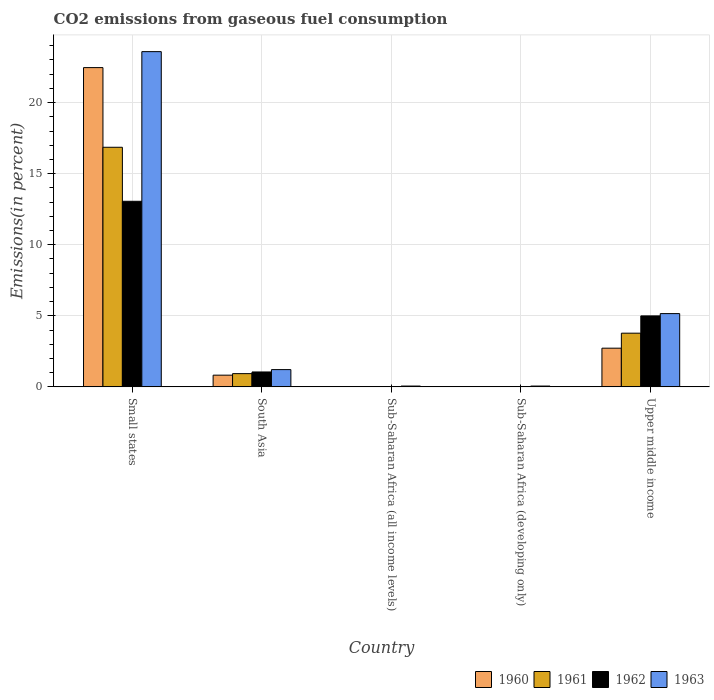How many different coloured bars are there?
Offer a terse response. 4. Are the number of bars on each tick of the X-axis equal?
Offer a terse response. Yes. How many bars are there on the 5th tick from the left?
Your answer should be very brief. 4. How many bars are there on the 2nd tick from the right?
Ensure brevity in your answer.  4. What is the label of the 1st group of bars from the left?
Your response must be concise. Small states. In how many cases, is the number of bars for a given country not equal to the number of legend labels?
Provide a succinct answer. 0. What is the total CO2 emitted in 1963 in Small states?
Provide a short and direct response. 23.59. Across all countries, what is the maximum total CO2 emitted in 1962?
Your answer should be compact. 13.06. Across all countries, what is the minimum total CO2 emitted in 1962?
Your answer should be compact. 0.01. In which country was the total CO2 emitted in 1962 maximum?
Make the answer very short. Small states. In which country was the total CO2 emitted in 1960 minimum?
Provide a succinct answer. Sub-Saharan Africa (all income levels). What is the total total CO2 emitted in 1962 in the graph?
Keep it short and to the point. 19.13. What is the difference between the total CO2 emitted in 1962 in Small states and that in Sub-Saharan Africa (all income levels)?
Ensure brevity in your answer.  13.04. What is the difference between the total CO2 emitted in 1960 in South Asia and the total CO2 emitted in 1962 in Sub-Saharan Africa (developing only)?
Offer a terse response. 0.81. What is the average total CO2 emitted in 1961 per country?
Give a very brief answer. 4.32. What is the difference between the total CO2 emitted of/in 1960 and total CO2 emitted of/in 1963 in Sub-Saharan Africa (developing only)?
Give a very brief answer. -0.05. In how many countries, is the total CO2 emitted in 1960 greater than 23 %?
Give a very brief answer. 0. What is the ratio of the total CO2 emitted in 1961 in Sub-Saharan Africa (developing only) to that in Upper middle income?
Keep it short and to the point. 0. Is the total CO2 emitted in 1963 in Small states less than that in Sub-Saharan Africa (developing only)?
Ensure brevity in your answer.  No. What is the difference between the highest and the second highest total CO2 emitted in 1961?
Make the answer very short. 15.93. What is the difference between the highest and the lowest total CO2 emitted in 1962?
Your answer should be compact. 13.04. In how many countries, is the total CO2 emitted in 1962 greater than the average total CO2 emitted in 1962 taken over all countries?
Your answer should be compact. 2. Is it the case that in every country, the sum of the total CO2 emitted in 1962 and total CO2 emitted in 1960 is greater than the sum of total CO2 emitted in 1961 and total CO2 emitted in 1963?
Keep it short and to the point. No. What does the 4th bar from the left in Sub-Saharan Africa (all income levels) represents?
Provide a short and direct response. 1963. What does the 2nd bar from the right in Sub-Saharan Africa (developing only) represents?
Offer a terse response. 1962. Is it the case that in every country, the sum of the total CO2 emitted in 1963 and total CO2 emitted in 1962 is greater than the total CO2 emitted in 1961?
Ensure brevity in your answer.  Yes. How many countries are there in the graph?
Offer a terse response. 5. What is the difference between two consecutive major ticks on the Y-axis?
Offer a terse response. 5. What is the title of the graph?
Ensure brevity in your answer.  CO2 emissions from gaseous fuel consumption. Does "1970" appear as one of the legend labels in the graph?
Ensure brevity in your answer.  No. What is the label or title of the X-axis?
Offer a very short reply. Country. What is the label or title of the Y-axis?
Offer a very short reply. Emissions(in percent). What is the Emissions(in percent) in 1960 in Small states?
Provide a short and direct response. 22.46. What is the Emissions(in percent) in 1961 in Small states?
Provide a succinct answer. 16.86. What is the Emissions(in percent) of 1962 in Small states?
Offer a very short reply. 13.06. What is the Emissions(in percent) in 1963 in Small states?
Keep it short and to the point. 23.59. What is the Emissions(in percent) in 1960 in South Asia?
Provide a short and direct response. 0.82. What is the Emissions(in percent) in 1961 in South Asia?
Your response must be concise. 0.93. What is the Emissions(in percent) of 1962 in South Asia?
Provide a succinct answer. 1.05. What is the Emissions(in percent) of 1963 in South Asia?
Offer a terse response. 1.22. What is the Emissions(in percent) of 1960 in Sub-Saharan Africa (all income levels)?
Give a very brief answer. 0.01. What is the Emissions(in percent) in 1961 in Sub-Saharan Africa (all income levels)?
Provide a short and direct response. 0.01. What is the Emissions(in percent) in 1962 in Sub-Saharan Africa (all income levels)?
Provide a succinct answer. 0.01. What is the Emissions(in percent) in 1963 in Sub-Saharan Africa (all income levels)?
Your answer should be very brief. 0.06. What is the Emissions(in percent) in 1960 in Sub-Saharan Africa (developing only)?
Offer a very short reply. 0.01. What is the Emissions(in percent) of 1961 in Sub-Saharan Africa (developing only)?
Your answer should be very brief. 0.01. What is the Emissions(in percent) of 1962 in Sub-Saharan Africa (developing only)?
Your response must be concise. 0.01. What is the Emissions(in percent) of 1963 in Sub-Saharan Africa (developing only)?
Your answer should be very brief. 0.06. What is the Emissions(in percent) in 1960 in Upper middle income?
Provide a succinct answer. 2.72. What is the Emissions(in percent) in 1961 in Upper middle income?
Your answer should be very brief. 3.78. What is the Emissions(in percent) of 1962 in Upper middle income?
Offer a very short reply. 4.99. What is the Emissions(in percent) of 1963 in Upper middle income?
Keep it short and to the point. 5.15. Across all countries, what is the maximum Emissions(in percent) in 1960?
Your answer should be compact. 22.46. Across all countries, what is the maximum Emissions(in percent) of 1961?
Give a very brief answer. 16.86. Across all countries, what is the maximum Emissions(in percent) of 1962?
Your response must be concise. 13.06. Across all countries, what is the maximum Emissions(in percent) in 1963?
Make the answer very short. 23.59. Across all countries, what is the minimum Emissions(in percent) of 1960?
Your answer should be very brief. 0.01. Across all countries, what is the minimum Emissions(in percent) of 1961?
Keep it short and to the point. 0.01. Across all countries, what is the minimum Emissions(in percent) of 1962?
Offer a very short reply. 0.01. Across all countries, what is the minimum Emissions(in percent) of 1963?
Your response must be concise. 0.06. What is the total Emissions(in percent) in 1960 in the graph?
Ensure brevity in your answer.  26.03. What is the total Emissions(in percent) of 1961 in the graph?
Your response must be concise. 21.59. What is the total Emissions(in percent) in 1962 in the graph?
Offer a terse response. 19.13. What is the total Emissions(in percent) in 1963 in the graph?
Ensure brevity in your answer.  30.07. What is the difference between the Emissions(in percent) of 1960 in Small states and that in South Asia?
Keep it short and to the point. 21.64. What is the difference between the Emissions(in percent) in 1961 in Small states and that in South Asia?
Your response must be concise. 15.93. What is the difference between the Emissions(in percent) of 1962 in Small states and that in South Asia?
Your answer should be very brief. 12.01. What is the difference between the Emissions(in percent) in 1963 in Small states and that in South Asia?
Keep it short and to the point. 22.37. What is the difference between the Emissions(in percent) in 1960 in Small states and that in Sub-Saharan Africa (all income levels)?
Make the answer very short. 22.45. What is the difference between the Emissions(in percent) in 1961 in Small states and that in Sub-Saharan Africa (all income levels)?
Make the answer very short. 16.85. What is the difference between the Emissions(in percent) of 1962 in Small states and that in Sub-Saharan Africa (all income levels)?
Offer a very short reply. 13.04. What is the difference between the Emissions(in percent) in 1963 in Small states and that in Sub-Saharan Africa (all income levels)?
Offer a terse response. 23.53. What is the difference between the Emissions(in percent) in 1960 in Small states and that in Sub-Saharan Africa (developing only)?
Give a very brief answer. 22.45. What is the difference between the Emissions(in percent) of 1961 in Small states and that in Sub-Saharan Africa (developing only)?
Give a very brief answer. 16.85. What is the difference between the Emissions(in percent) in 1962 in Small states and that in Sub-Saharan Africa (developing only)?
Ensure brevity in your answer.  13.04. What is the difference between the Emissions(in percent) of 1963 in Small states and that in Sub-Saharan Africa (developing only)?
Your answer should be compact. 23.53. What is the difference between the Emissions(in percent) of 1960 in Small states and that in Upper middle income?
Ensure brevity in your answer.  19.74. What is the difference between the Emissions(in percent) of 1961 in Small states and that in Upper middle income?
Provide a short and direct response. 13.08. What is the difference between the Emissions(in percent) of 1962 in Small states and that in Upper middle income?
Offer a terse response. 8.06. What is the difference between the Emissions(in percent) of 1963 in Small states and that in Upper middle income?
Offer a terse response. 18.43. What is the difference between the Emissions(in percent) in 1960 in South Asia and that in Sub-Saharan Africa (all income levels)?
Provide a succinct answer. 0.81. What is the difference between the Emissions(in percent) of 1961 in South Asia and that in Sub-Saharan Africa (all income levels)?
Keep it short and to the point. 0.92. What is the difference between the Emissions(in percent) in 1962 in South Asia and that in Sub-Saharan Africa (all income levels)?
Keep it short and to the point. 1.03. What is the difference between the Emissions(in percent) of 1963 in South Asia and that in Sub-Saharan Africa (all income levels)?
Keep it short and to the point. 1.16. What is the difference between the Emissions(in percent) of 1960 in South Asia and that in Sub-Saharan Africa (developing only)?
Make the answer very short. 0.81. What is the difference between the Emissions(in percent) in 1961 in South Asia and that in Sub-Saharan Africa (developing only)?
Provide a short and direct response. 0.92. What is the difference between the Emissions(in percent) in 1962 in South Asia and that in Sub-Saharan Africa (developing only)?
Your answer should be compact. 1.03. What is the difference between the Emissions(in percent) of 1963 in South Asia and that in Sub-Saharan Africa (developing only)?
Your answer should be very brief. 1.16. What is the difference between the Emissions(in percent) of 1960 in South Asia and that in Upper middle income?
Offer a terse response. -1.9. What is the difference between the Emissions(in percent) of 1961 in South Asia and that in Upper middle income?
Make the answer very short. -2.85. What is the difference between the Emissions(in percent) of 1962 in South Asia and that in Upper middle income?
Your answer should be compact. -3.94. What is the difference between the Emissions(in percent) in 1963 in South Asia and that in Upper middle income?
Your answer should be very brief. -3.94. What is the difference between the Emissions(in percent) of 1960 in Sub-Saharan Africa (all income levels) and that in Sub-Saharan Africa (developing only)?
Your answer should be compact. -0. What is the difference between the Emissions(in percent) in 1961 in Sub-Saharan Africa (all income levels) and that in Sub-Saharan Africa (developing only)?
Your response must be concise. -0. What is the difference between the Emissions(in percent) in 1962 in Sub-Saharan Africa (all income levels) and that in Sub-Saharan Africa (developing only)?
Offer a very short reply. -0. What is the difference between the Emissions(in percent) of 1963 in Sub-Saharan Africa (all income levels) and that in Sub-Saharan Africa (developing only)?
Your response must be concise. -0. What is the difference between the Emissions(in percent) of 1960 in Sub-Saharan Africa (all income levels) and that in Upper middle income?
Offer a terse response. -2.71. What is the difference between the Emissions(in percent) of 1961 in Sub-Saharan Africa (all income levels) and that in Upper middle income?
Your answer should be very brief. -3.77. What is the difference between the Emissions(in percent) of 1962 in Sub-Saharan Africa (all income levels) and that in Upper middle income?
Give a very brief answer. -4.98. What is the difference between the Emissions(in percent) of 1963 in Sub-Saharan Africa (all income levels) and that in Upper middle income?
Provide a succinct answer. -5.1. What is the difference between the Emissions(in percent) of 1960 in Sub-Saharan Africa (developing only) and that in Upper middle income?
Provide a succinct answer. -2.71. What is the difference between the Emissions(in percent) of 1961 in Sub-Saharan Africa (developing only) and that in Upper middle income?
Offer a very short reply. -3.77. What is the difference between the Emissions(in percent) in 1962 in Sub-Saharan Africa (developing only) and that in Upper middle income?
Provide a succinct answer. -4.98. What is the difference between the Emissions(in percent) of 1963 in Sub-Saharan Africa (developing only) and that in Upper middle income?
Give a very brief answer. -5.1. What is the difference between the Emissions(in percent) of 1960 in Small states and the Emissions(in percent) of 1961 in South Asia?
Ensure brevity in your answer.  21.53. What is the difference between the Emissions(in percent) of 1960 in Small states and the Emissions(in percent) of 1962 in South Asia?
Keep it short and to the point. 21.41. What is the difference between the Emissions(in percent) of 1960 in Small states and the Emissions(in percent) of 1963 in South Asia?
Your answer should be very brief. 21.25. What is the difference between the Emissions(in percent) of 1961 in Small states and the Emissions(in percent) of 1962 in South Asia?
Offer a terse response. 15.81. What is the difference between the Emissions(in percent) of 1961 in Small states and the Emissions(in percent) of 1963 in South Asia?
Provide a short and direct response. 15.64. What is the difference between the Emissions(in percent) in 1962 in Small states and the Emissions(in percent) in 1963 in South Asia?
Offer a terse response. 11.84. What is the difference between the Emissions(in percent) of 1960 in Small states and the Emissions(in percent) of 1961 in Sub-Saharan Africa (all income levels)?
Your response must be concise. 22.45. What is the difference between the Emissions(in percent) of 1960 in Small states and the Emissions(in percent) of 1962 in Sub-Saharan Africa (all income levels)?
Your response must be concise. 22.45. What is the difference between the Emissions(in percent) of 1960 in Small states and the Emissions(in percent) of 1963 in Sub-Saharan Africa (all income levels)?
Provide a succinct answer. 22.4. What is the difference between the Emissions(in percent) in 1961 in Small states and the Emissions(in percent) in 1962 in Sub-Saharan Africa (all income levels)?
Make the answer very short. 16.84. What is the difference between the Emissions(in percent) in 1961 in Small states and the Emissions(in percent) in 1963 in Sub-Saharan Africa (all income levels)?
Ensure brevity in your answer.  16.8. What is the difference between the Emissions(in percent) in 1962 in Small states and the Emissions(in percent) in 1963 in Sub-Saharan Africa (all income levels)?
Provide a succinct answer. 13. What is the difference between the Emissions(in percent) of 1960 in Small states and the Emissions(in percent) of 1961 in Sub-Saharan Africa (developing only)?
Provide a short and direct response. 22.45. What is the difference between the Emissions(in percent) of 1960 in Small states and the Emissions(in percent) of 1962 in Sub-Saharan Africa (developing only)?
Offer a terse response. 22.45. What is the difference between the Emissions(in percent) of 1960 in Small states and the Emissions(in percent) of 1963 in Sub-Saharan Africa (developing only)?
Keep it short and to the point. 22.4. What is the difference between the Emissions(in percent) of 1961 in Small states and the Emissions(in percent) of 1962 in Sub-Saharan Africa (developing only)?
Offer a terse response. 16.84. What is the difference between the Emissions(in percent) in 1961 in Small states and the Emissions(in percent) in 1963 in Sub-Saharan Africa (developing only)?
Ensure brevity in your answer.  16.8. What is the difference between the Emissions(in percent) in 1962 in Small states and the Emissions(in percent) in 1963 in Sub-Saharan Africa (developing only)?
Offer a very short reply. 13. What is the difference between the Emissions(in percent) in 1960 in Small states and the Emissions(in percent) in 1961 in Upper middle income?
Make the answer very short. 18.69. What is the difference between the Emissions(in percent) in 1960 in Small states and the Emissions(in percent) in 1962 in Upper middle income?
Offer a terse response. 17.47. What is the difference between the Emissions(in percent) in 1960 in Small states and the Emissions(in percent) in 1963 in Upper middle income?
Offer a very short reply. 17.31. What is the difference between the Emissions(in percent) in 1961 in Small states and the Emissions(in percent) in 1962 in Upper middle income?
Provide a short and direct response. 11.86. What is the difference between the Emissions(in percent) of 1961 in Small states and the Emissions(in percent) of 1963 in Upper middle income?
Keep it short and to the point. 11.7. What is the difference between the Emissions(in percent) in 1962 in Small states and the Emissions(in percent) in 1963 in Upper middle income?
Make the answer very short. 7.9. What is the difference between the Emissions(in percent) in 1960 in South Asia and the Emissions(in percent) in 1961 in Sub-Saharan Africa (all income levels)?
Ensure brevity in your answer.  0.81. What is the difference between the Emissions(in percent) of 1960 in South Asia and the Emissions(in percent) of 1962 in Sub-Saharan Africa (all income levels)?
Give a very brief answer. 0.81. What is the difference between the Emissions(in percent) in 1960 in South Asia and the Emissions(in percent) in 1963 in Sub-Saharan Africa (all income levels)?
Your response must be concise. 0.77. What is the difference between the Emissions(in percent) in 1961 in South Asia and the Emissions(in percent) in 1962 in Sub-Saharan Africa (all income levels)?
Offer a terse response. 0.92. What is the difference between the Emissions(in percent) of 1961 in South Asia and the Emissions(in percent) of 1963 in Sub-Saharan Africa (all income levels)?
Keep it short and to the point. 0.87. What is the difference between the Emissions(in percent) of 1960 in South Asia and the Emissions(in percent) of 1961 in Sub-Saharan Africa (developing only)?
Your answer should be compact. 0.81. What is the difference between the Emissions(in percent) in 1960 in South Asia and the Emissions(in percent) in 1962 in Sub-Saharan Africa (developing only)?
Your response must be concise. 0.81. What is the difference between the Emissions(in percent) in 1960 in South Asia and the Emissions(in percent) in 1963 in Sub-Saharan Africa (developing only)?
Your answer should be compact. 0.77. What is the difference between the Emissions(in percent) in 1961 in South Asia and the Emissions(in percent) in 1962 in Sub-Saharan Africa (developing only)?
Offer a very short reply. 0.92. What is the difference between the Emissions(in percent) in 1961 in South Asia and the Emissions(in percent) in 1963 in Sub-Saharan Africa (developing only)?
Make the answer very short. 0.87. What is the difference between the Emissions(in percent) of 1962 in South Asia and the Emissions(in percent) of 1963 in Sub-Saharan Africa (developing only)?
Provide a succinct answer. 0.99. What is the difference between the Emissions(in percent) in 1960 in South Asia and the Emissions(in percent) in 1961 in Upper middle income?
Offer a terse response. -2.95. What is the difference between the Emissions(in percent) in 1960 in South Asia and the Emissions(in percent) in 1962 in Upper middle income?
Offer a very short reply. -4.17. What is the difference between the Emissions(in percent) of 1960 in South Asia and the Emissions(in percent) of 1963 in Upper middle income?
Your response must be concise. -4.33. What is the difference between the Emissions(in percent) of 1961 in South Asia and the Emissions(in percent) of 1962 in Upper middle income?
Make the answer very short. -4.06. What is the difference between the Emissions(in percent) of 1961 in South Asia and the Emissions(in percent) of 1963 in Upper middle income?
Provide a succinct answer. -4.22. What is the difference between the Emissions(in percent) of 1962 in South Asia and the Emissions(in percent) of 1963 in Upper middle income?
Provide a short and direct response. -4.11. What is the difference between the Emissions(in percent) in 1960 in Sub-Saharan Africa (all income levels) and the Emissions(in percent) in 1962 in Sub-Saharan Africa (developing only)?
Your answer should be very brief. -0. What is the difference between the Emissions(in percent) of 1960 in Sub-Saharan Africa (all income levels) and the Emissions(in percent) of 1963 in Sub-Saharan Africa (developing only)?
Your response must be concise. -0.05. What is the difference between the Emissions(in percent) in 1961 in Sub-Saharan Africa (all income levels) and the Emissions(in percent) in 1962 in Sub-Saharan Africa (developing only)?
Provide a succinct answer. -0. What is the difference between the Emissions(in percent) in 1961 in Sub-Saharan Africa (all income levels) and the Emissions(in percent) in 1963 in Sub-Saharan Africa (developing only)?
Ensure brevity in your answer.  -0.05. What is the difference between the Emissions(in percent) of 1962 in Sub-Saharan Africa (all income levels) and the Emissions(in percent) of 1963 in Sub-Saharan Africa (developing only)?
Make the answer very short. -0.04. What is the difference between the Emissions(in percent) of 1960 in Sub-Saharan Africa (all income levels) and the Emissions(in percent) of 1961 in Upper middle income?
Ensure brevity in your answer.  -3.77. What is the difference between the Emissions(in percent) in 1960 in Sub-Saharan Africa (all income levels) and the Emissions(in percent) in 1962 in Upper middle income?
Your answer should be compact. -4.98. What is the difference between the Emissions(in percent) of 1960 in Sub-Saharan Africa (all income levels) and the Emissions(in percent) of 1963 in Upper middle income?
Make the answer very short. -5.14. What is the difference between the Emissions(in percent) in 1961 in Sub-Saharan Africa (all income levels) and the Emissions(in percent) in 1962 in Upper middle income?
Offer a terse response. -4.98. What is the difference between the Emissions(in percent) of 1961 in Sub-Saharan Africa (all income levels) and the Emissions(in percent) of 1963 in Upper middle income?
Your response must be concise. -5.14. What is the difference between the Emissions(in percent) of 1962 in Sub-Saharan Africa (all income levels) and the Emissions(in percent) of 1963 in Upper middle income?
Give a very brief answer. -5.14. What is the difference between the Emissions(in percent) of 1960 in Sub-Saharan Africa (developing only) and the Emissions(in percent) of 1961 in Upper middle income?
Give a very brief answer. -3.77. What is the difference between the Emissions(in percent) in 1960 in Sub-Saharan Africa (developing only) and the Emissions(in percent) in 1962 in Upper middle income?
Your answer should be very brief. -4.98. What is the difference between the Emissions(in percent) in 1960 in Sub-Saharan Africa (developing only) and the Emissions(in percent) in 1963 in Upper middle income?
Ensure brevity in your answer.  -5.14. What is the difference between the Emissions(in percent) of 1961 in Sub-Saharan Africa (developing only) and the Emissions(in percent) of 1962 in Upper middle income?
Your answer should be compact. -4.98. What is the difference between the Emissions(in percent) of 1961 in Sub-Saharan Africa (developing only) and the Emissions(in percent) of 1963 in Upper middle income?
Offer a terse response. -5.14. What is the difference between the Emissions(in percent) in 1962 in Sub-Saharan Africa (developing only) and the Emissions(in percent) in 1963 in Upper middle income?
Offer a terse response. -5.14. What is the average Emissions(in percent) of 1960 per country?
Provide a succinct answer. 5.21. What is the average Emissions(in percent) in 1961 per country?
Give a very brief answer. 4.32. What is the average Emissions(in percent) of 1962 per country?
Your answer should be compact. 3.83. What is the average Emissions(in percent) of 1963 per country?
Your response must be concise. 6.01. What is the difference between the Emissions(in percent) in 1960 and Emissions(in percent) in 1961 in Small states?
Offer a terse response. 5.6. What is the difference between the Emissions(in percent) of 1960 and Emissions(in percent) of 1962 in Small states?
Offer a terse response. 9.41. What is the difference between the Emissions(in percent) of 1960 and Emissions(in percent) of 1963 in Small states?
Provide a short and direct response. -1.12. What is the difference between the Emissions(in percent) of 1961 and Emissions(in percent) of 1962 in Small states?
Your answer should be very brief. 3.8. What is the difference between the Emissions(in percent) in 1961 and Emissions(in percent) in 1963 in Small states?
Offer a very short reply. -6.73. What is the difference between the Emissions(in percent) in 1962 and Emissions(in percent) in 1963 in Small states?
Provide a succinct answer. -10.53. What is the difference between the Emissions(in percent) in 1960 and Emissions(in percent) in 1961 in South Asia?
Your answer should be very brief. -0.11. What is the difference between the Emissions(in percent) in 1960 and Emissions(in percent) in 1962 in South Asia?
Provide a short and direct response. -0.22. What is the difference between the Emissions(in percent) of 1960 and Emissions(in percent) of 1963 in South Asia?
Ensure brevity in your answer.  -0.39. What is the difference between the Emissions(in percent) of 1961 and Emissions(in percent) of 1962 in South Asia?
Provide a succinct answer. -0.12. What is the difference between the Emissions(in percent) in 1961 and Emissions(in percent) in 1963 in South Asia?
Offer a terse response. -0.28. What is the difference between the Emissions(in percent) of 1962 and Emissions(in percent) of 1963 in South Asia?
Ensure brevity in your answer.  -0.17. What is the difference between the Emissions(in percent) in 1960 and Emissions(in percent) in 1961 in Sub-Saharan Africa (all income levels)?
Give a very brief answer. 0. What is the difference between the Emissions(in percent) of 1960 and Emissions(in percent) of 1962 in Sub-Saharan Africa (all income levels)?
Provide a succinct answer. -0. What is the difference between the Emissions(in percent) of 1960 and Emissions(in percent) of 1963 in Sub-Saharan Africa (all income levels)?
Your response must be concise. -0.05. What is the difference between the Emissions(in percent) in 1961 and Emissions(in percent) in 1962 in Sub-Saharan Africa (all income levels)?
Offer a terse response. -0. What is the difference between the Emissions(in percent) of 1961 and Emissions(in percent) of 1963 in Sub-Saharan Africa (all income levels)?
Keep it short and to the point. -0.05. What is the difference between the Emissions(in percent) in 1962 and Emissions(in percent) in 1963 in Sub-Saharan Africa (all income levels)?
Your response must be concise. -0.04. What is the difference between the Emissions(in percent) in 1960 and Emissions(in percent) in 1961 in Sub-Saharan Africa (developing only)?
Provide a short and direct response. 0. What is the difference between the Emissions(in percent) in 1960 and Emissions(in percent) in 1962 in Sub-Saharan Africa (developing only)?
Offer a very short reply. -0. What is the difference between the Emissions(in percent) of 1960 and Emissions(in percent) of 1963 in Sub-Saharan Africa (developing only)?
Keep it short and to the point. -0.05. What is the difference between the Emissions(in percent) in 1961 and Emissions(in percent) in 1962 in Sub-Saharan Africa (developing only)?
Your response must be concise. -0. What is the difference between the Emissions(in percent) in 1961 and Emissions(in percent) in 1963 in Sub-Saharan Africa (developing only)?
Offer a very short reply. -0.05. What is the difference between the Emissions(in percent) of 1962 and Emissions(in percent) of 1963 in Sub-Saharan Africa (developing only)?
Your answer should be compact. -0.04. What is the difference between the Emissions(in percent) of 1960 and Emissions(in percent) of 1961 in Upper middle income?
Provide a short and direct response. -1.06. What is the difference between the Emissions(in percent) of 1960 and Emissions(in percent) of 1962 in Upper middle income?
Your response must be concise. -2.27. What is the difference between the Emissions(in percent) of 1960 and Emissions(in percent) of 1963 in Upper middle income?
Your answer should be compact. -2.43. What is the difference between the Emissions(in percent) of 1961 and Emissions(in percent) of 1962 in Upper middle income?
Provide a succinct answer. -1.22. What is the difference between the Emissions(in percent) in 1961 and Emissions(in percent) in 1963 in Upper middle income?
Ensure brevity in your answer.  -1.38. What is the difference between the Emissions(in percent) of 1962 and Emissions(in percent) of 1963 in Upper middle income?
Make the answer very short. -0.16. What is the ratio of the Emissions(in percent) of 1960 in Small states to that in South Asia?
Provide a short and direct response. 27.26. What is the ratio of the Emissions(in percent) of 1961 in Small states to that in South Asia?
Keep it short and to the point. 18.09. What is the ratio of the Emissions(in percent) in 1962 in Small states to that in South Asia?
Your answer should be very brief. 12.45. What is the ratio of the Emissions(in percent) in 1963 in Small states to that in South Asia?
Give a very brief answer. 19.41. What is the ratio of the Emissions(in percent) in 1960 in Small states to that in Sub-Saharan Africa (all income levels)?
Offer a terse response. 1801.95. What is the ratio of the Emissions(in percent) of 1961 in Small states to that in Sub-Saharan Africa (all income levels)?
Ensure brevity in your answer.  1414.45. What is the ratio of the Emissions(in percent) in 1962 in Small states to that in Sub-Saharan Africa (all income levels)?
Provide a short and direct response. 907.48. What is the ratio of the Emissions(in percent) of 1963 in Small states to that in Sub-Saharan Africa (all income levels)?
Your answer should be very brief. 409.19. What is the ratio of the Emissions(in percent) of 1960 in Small states to that in Sub-Saharan Africa (developing only)?
Provide a succinct answer. 1801.61. What is the ratio of the Emissions(in percent) in 1961 in Small states to that in Sub-Saharan Africa (developing only)?
Offer a terse response. 1414.2. What is the ratio of the Emissions(in percent) of 1962 in Small states to that in Sub-Saharan Africa (developing only)?
Make the answer very short. 907.33. What is the ratio of the Emissions(in percent) in 1963 in Small states to that in Sub-Saharan Africa (developing only)?
Provide a short and direct response. 409.09. What is the ratio of the Emissions(in percent) in 1960 in Small states to that in Upper middle income?
Your response must be concise. 8.25. What is the ratio of the Emissions(in percent) in 1961 in Small states to that in Upper middle income?
Keep it short and to the point. 4.46. What is the ratio of the Emissions(in percent) in 1962 in Small states to that in Upper middle income?
Your answer should be compact. 2.62. What is the ratio of the Emissions(in percent) in 1963 in Small states to that in Upper middle income?
Provide a short and direct response. 4.58. What is the ratio of the Emissions(in percent) in 1960 in South Asia to that in Sub-Saharan Africa (all income levels)?
Offer a very short reply. 66.11. What is the ratio of the Emissions(in percent) of 1961 in South Asia to that in Sub-Saharan Africa (all income levels)?
Give a very brief answer. 78.18. What is the ratio of the Emissions(in percent) in 1962 in South Asia to that in Sub-Saharan Africa (all income levels)?
Offer a terse response. 72.9. What is the ratio of the Emissions(in percent) of 1963 in South Asia to that in Sub-Saharan Africa (all income levels)?
Make the answer very short. 21.08. What is the ratio of the Emissions(in percent) in 1960 in South Asia to that in Sub-Saharan Africa (developing only)?
Ensure brevity in your answer.  66.1. What is the ratio of the Emissions(in percent) in 1961 in South Asia to that in Sub-Saharan Africa (developing only)?
Make the answer very short. 78.17. What is the ratio of the Emissions(in percent) in 1962 in South Asia to that in Sub-Saharan Africa (developing only)?
Offer a terse response. 72.89. What is the ratio of the Emissions(in percent) in 1963 in South Asia to that in Sub-Saharan Africa (developing only)?
Ensure brevity in your answer.  21.08. What is the ratio of the Emissions(in percent) of 1960 in South Asia to that in Upper middle income?
Provide a succinct answer. 0.3. What is the ratio of the Emissions(in percent) in 1961 in South Asia to that in Upper middle income?
Your answer should be very brief. 0.25. What is the ratio of the Emissions(in percent) in 1962 in South Asia to that in Upper middle income?
Provide a short and direct response. 0.21. What is the ratio of the Emissions(in percent) of 1963 in South Asia to that in Upper middle income?
Keep it short and to the point. 0.24. What is the ratio of the Emissions(in percent) of 1961 in Sub-Saharan Africa (all income levels) to that in Sub-Saharan Africa (developing only)?
Offer a very short reply. 1. What is the ratio of the Emissions(in percent) of 1962 in Sub-Saharan Africa (all income levels) to that in Sub-Saharan Africa (developing only)?
Make the answer very short. 1. What is the ratio of the Emissions(in percent) of 1960 in Sub-Saharan Africa (all income levels) to that in Upper middle income?
Give a very brief answer. 0. What is the ratio of the Emissions(in percent) of 1961 in Sub-Saharan Africa (all income levels) to that in Upper middle income?
Offer a terse response. 0. What is the ratio of the Emissions(in percent) of 1962 in Sub-Saharan Africa (all income levels) to that in Upper middle income?
Provide a short and direct response. 0. What is the ratio of the Emissions(in percent) of 1963 in Sub-Saharan Africa (all income levels) to that in Upper middle income?
Your answer should be compact. 0.01. What is the ratio of the Emissions(in percent) in 1960 in Sub-Saharan Africa (developing only) to that in Upper middle income?
Offer a very short reply. 0. What is the ratio of the Emissions(in percent) in 1961 in Sub-Saharan Africa (developing only) to that in Upper middle income?
Your answer should be very brief. 0. What is the ratio of the Emissions(in percent) in 1962 in Sub-Saharan Africa (developing only) to that in Upper middle income?
Provide a short and direct response. 0. What is the ratio of the Emissions(in percent) in 1963 in Sub-Saharan Africa (developing only) to that in Upper middle income?
Offer a terse response. 0.01. What is the difference between the highest and the second highest Emissions(in percent) in 1960?
Make the answer very short. 19.74. What is the difference between the highest and the second highest Emissions(in percent) in 1961?
Your answer should be very brief. 13.08. What is the difference between the highest and the second highest Emissions(in percent) in 1962?
Your answer should be compact. 8.06. What is the difference between the highest and the second highest Emissions(in percent) in 1963?
Provide a short and direct response. 18.43. What is the difference between the highest and the lowest Emissions(in percent) of 1960?
Provide a succinct answer. 22.45. What is the difference between the highest and the lowest Emissions(in percent) of 1961?
Keep it short and to the point. 16.85. What is the difference between the highest and the lowest Emissions(in percent) in 1962?
Give a very brief answer. 13.04. What is the difference between the highest and the lowest Emissions(in percent) in 1963?
Provide a short and direct response. 23.53. 